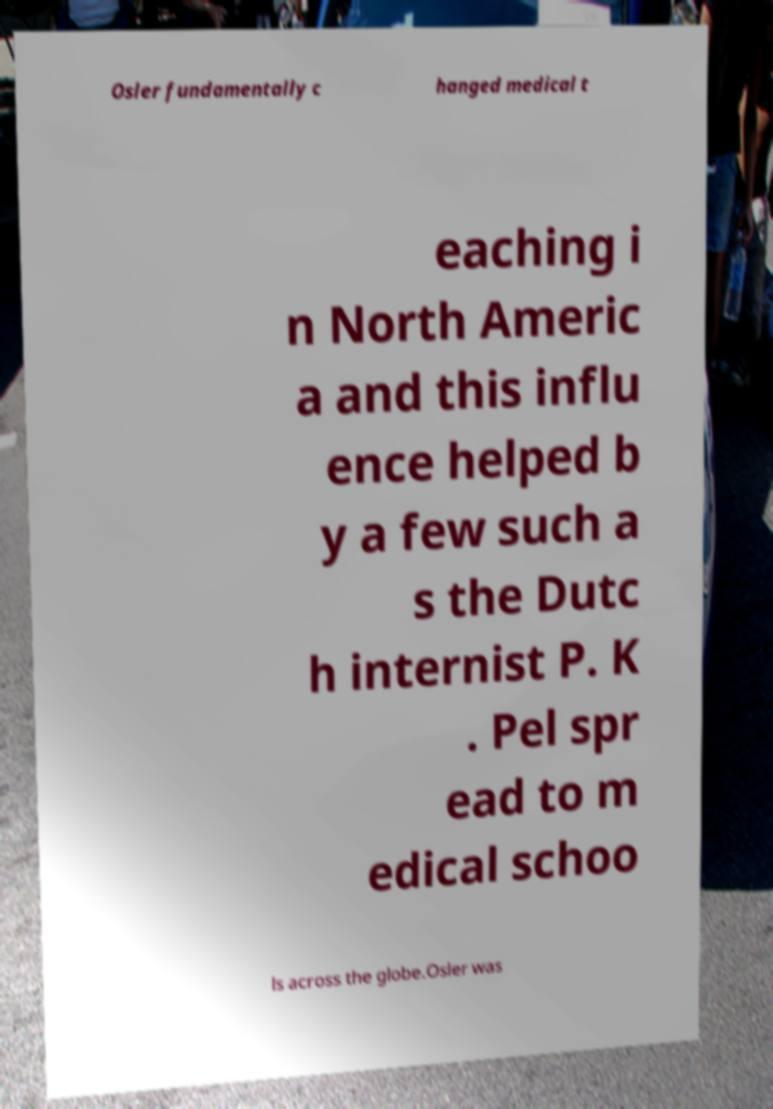For documentation purposes, I need the text within this image transcribed. Could you provide that? Osler fundamentally c hanged medical t eaching i n North Americ a and this influ ence helped b y a few such a s the Dutc h internist P. K . Pel spr ead to m edical schoo ls across the globe.Osler was 